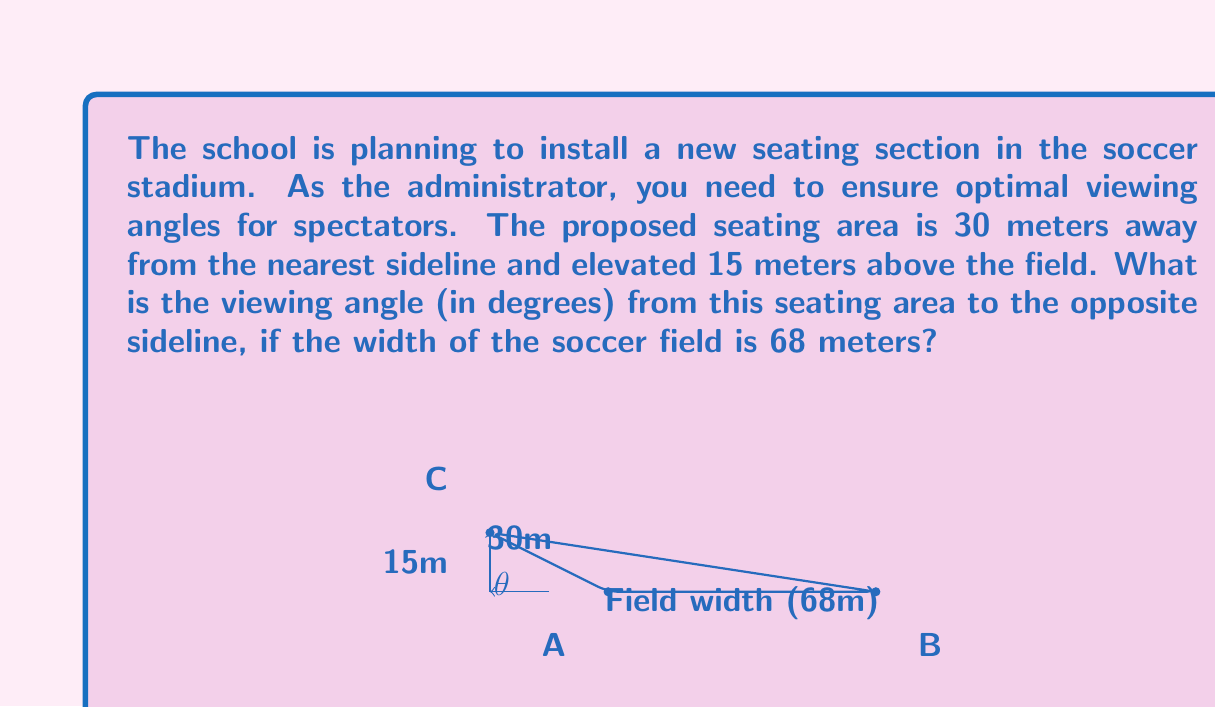Provide a solution to this math problem. To solve this problem, we need to use trigonometry. Let's approach this step-by-step:

1) First, we need to identify the right triangle formed by the viewing angle. The vertical leg is the height of the seating area (15m), and the horizontal leg is the total distance from the seating area to the far sideline.

2) The horizontal leg is composed of two parts: the distance to the near sideline (30m) and the width of the field (68m). So the total horizontal distance is 30 + 68 = 98m.

3) Now we have a right triangle with:
   - Adjacent side (horizontal) = 98m
   - Opposite side (vertical) = 15m

4) To find the angle, we need to use the arctangent function (tan^(-1) or atan). The tangent of an angle is the ratio of the opposite side to the adjacent side.

5) Let θ be the viewing angle. Then:

   $$\tan(\theta) = \frac{\text{opposite}}{\text{adjacent}} = \frac{15}{98}$$

6) To get θ, we take the arctangent of both sides:

   $$\theta = \tan^{-1}\left(\frac{15}{98}\right)$$

7) Using a calculator or computer:

   $$\theta \approx 8.71^\circ$$

Therefore, the viewing angle from the new seating area to the opposite sideline is approximately 8.71 degrees.
Answer: $8.71^\circ$ (rounded to two decimal places) 